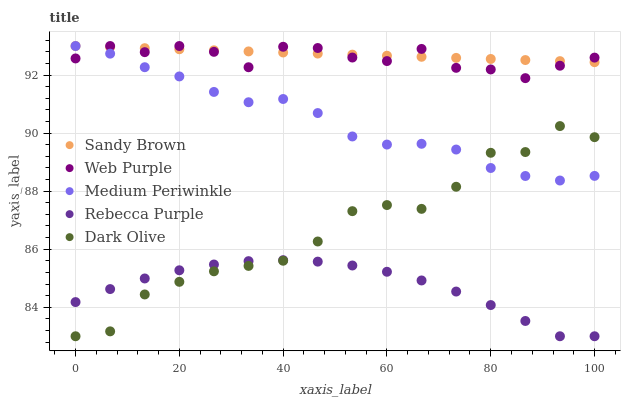Does Rebecca Purple have the minimum area under the curve?
Answer yes or no. Yes. Does Sandy Brown have the maximum area under the curve?
Answer yes or no. Yes. Does Web Purple have the minimum area under the curve?
Answer yes or no. No. Does Web Purple have the maximum area under the curve?
Answer yes or no. No. Is Sandy Brown the smoothest?
Answer yes or no. Yes. Is Dark Olive the roughest?
Answer yes or no. Yes. Is Web Purple the smoothest?
Answer yes or no. No. Is Web Purple the roughest?
Answer yes or no. No. Does Dark Olive have the lowest value?
Answer yes or no. Yes. Does Web Purple have the lowest value?
Answer yes or no. No. Does Sandy Brown have the highest value?
Answer yes or no. Yes. Does Dark Olive have the highest value?
Answer yes or no. No. Is Dark Olive less than Web Purple?
Answer yes or no. Yes. Is Sandy Brown greater than Rebecca Purple?
Answer yes or no. Yes. Does Sandy Brown intersect Medium Periwinkle?
Answer yes or no. Yes. Is Sandy Brown less than Medium Periwinkle?
Answer yes or no. No. Is Sandy Brown greater than Medium Periwinkle?
Answer yes or no. No. Does Dark Olive intersect Web Purple?
Answer yes or no. No. 